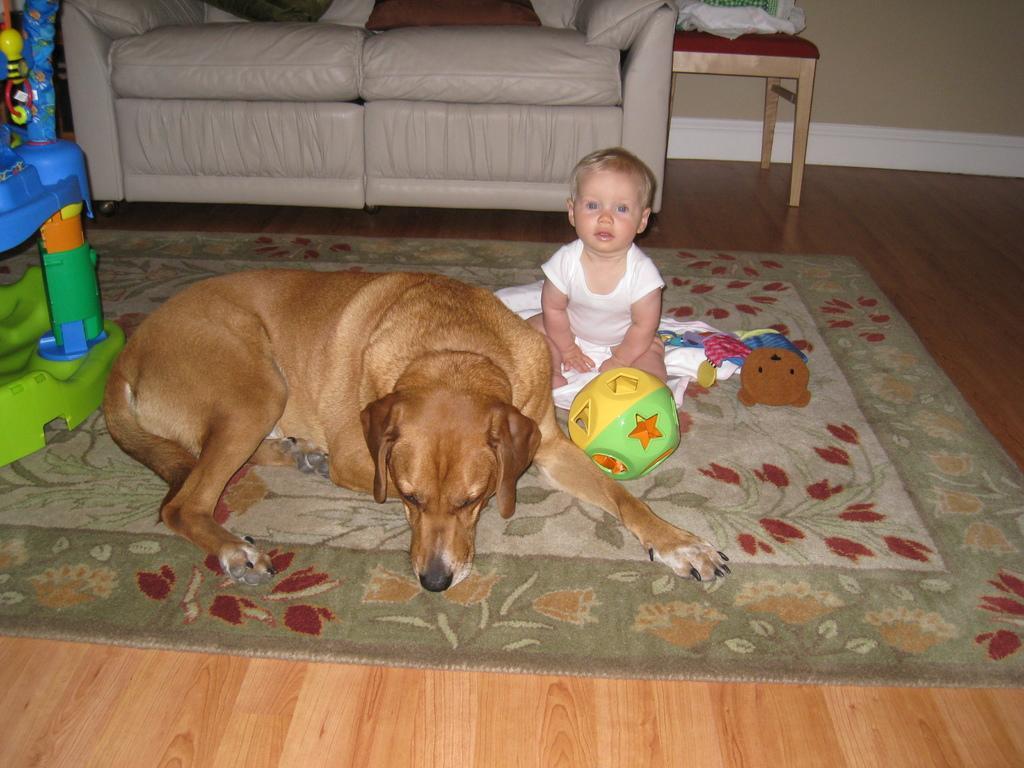How would you summarize this image in a sentence or two? In this image there is a dog, ball and baby on the carpet, beside the dog there is some object also there is a sofa and chair at the back. 